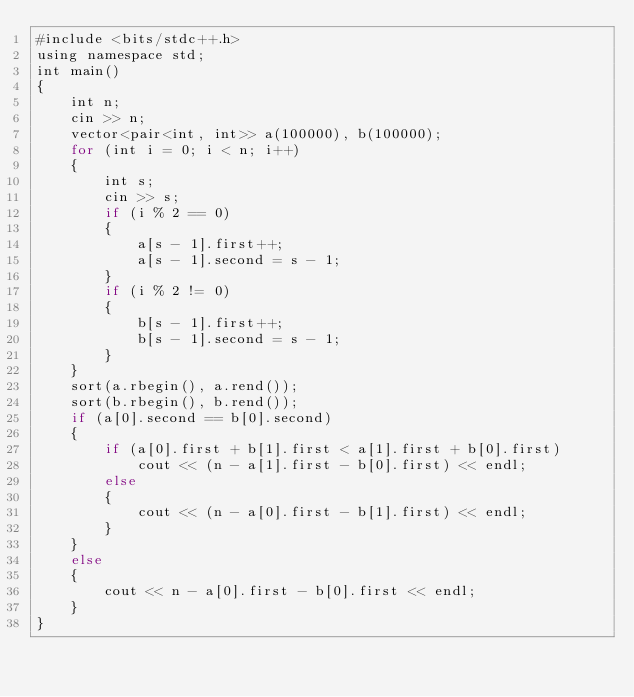<code> <loc_0><loc_0><loc_500><loc_500><_Rust_>#include <bits/stdc++.h>
using namespace std;
int main()
{
    int n;
    cin >> n;
    vector<pair<int, int>> a(100000), b(100000);
    for (int i = 0; i < n; i++)
    {
        int s;
        cin >> s;
        if (i % 2 == 0)
        {
            a[s - 1].first++;
            a[s - 1].second = s - 1;
        }
        if (i % 2 != 0)
        {
            b[s - 1].first++;
            b[s - 1].second = s - 1;
        }
    }
    sort(a.rbegin(), a.rend());
    sort(b.rbegin(), b.rend());
    if (a[0].second == b[0].second)
    {
        if (a[0].first + b[1].first < a[1].first + b[0].first)
            cout << (n - a[1].first - b[0].first) << endl;
        else
        {
            cout << (n - a[0].first - b[1].first) << endl;
        }
    }
    else
    {
        cout << n - a[0].first - b[0].first << endl;
    }
}</code> 